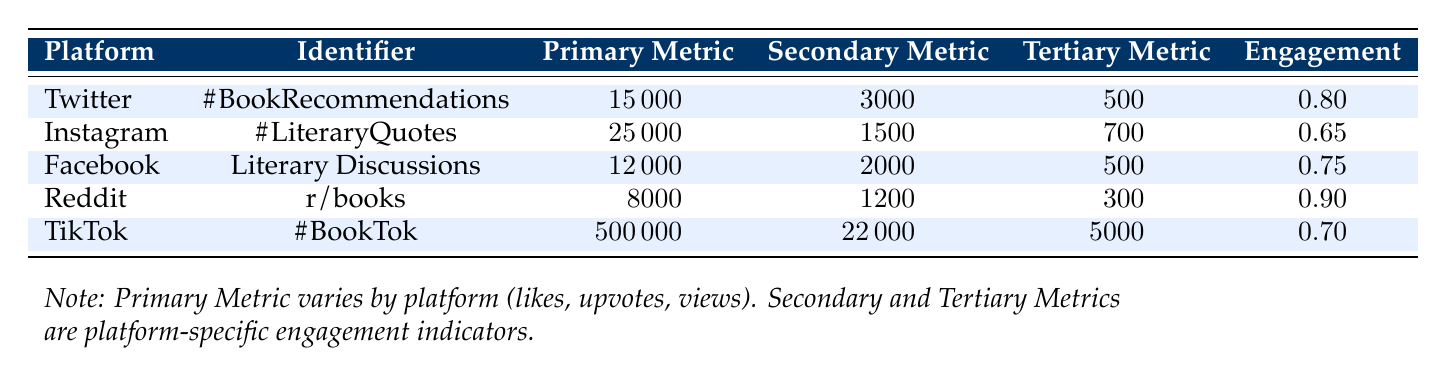What is the primary metric for Instagram? The primary metric for Instagram is likes, which is indicated in the table. Specifically, Instagram has 25,000 likes for the hashtag #LiteraryQuotes.
Answer: 25,000 Which platform has the highest engagement rate? By examining the engagement rates provided in the table, Reddit has an engagement rate of 0.9, which is the highest among all platforms listed.
Answer: 0.9 What is the total number of likes across all platforms? To find the total likes, we sum the likes from each platform: 15,000 (Twitter) + 25,000 (Instagram) + 12,000 (Facebook) + 8,000 (Reddit) + 22,000 (TikTok) = 82,000.
Answer: 82,000 Does Facebook have more comments than Twitter? Facebook has 2,000 comments, while Twitter has 500 comments as per the data in the table. Since 2,000 is greater than 500, the statement is true.
Answer: Yes What is the total number of interactions (likes, shares, comments, etc.) for TikTok? To calculate interactions for TikTok, we add the likes, shares, and views: 22,000 (likes) + 5,000 (shares) + 500,000 (views) = 527,000.
Answer: 527,000 Is the total number of shares for Instagram greater than that for Reddit? Instagram has 700 shares while Reddit has 300 shares. Since 700 is greater than 300, the statement is true.
Answer: Yes What is the average engagement rate across all platforms? The average engagement rate can be calculated by summing all engagement rates and dividing by the number of platforms: (0.8 + 0.65 + 0.75 + 0.9 + 0.7) / 5 = 0.78.
Answer: 0.78 How many more likes does Instagram have compared to Reddit? Instagram has 25,000 likes while Reddit has 8,000 likes. To find the difference, we calculate 25,000 - 8,000 = 17,000.
Answer: 17,000 Which platform had the fewest posts or submissions? The platform with the fewest submissions is Reddit, with a total of 300 posts, which is less than that of the other platforms listed in the table.
Answer: Reddit 